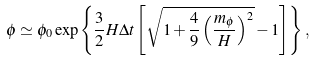Convert formula to latex. <formula><loc_0><loc_0><loc_500><loc_500>\phi \simeq \phi _ { 0 } \exp \left \{ \frac { 3 } { 2 } H \Delta t \left [ \sqrt { 1 + \frac { 4 } { 9 } \left ( \frac { m _ { \phi } } { H } \right ) ^ { 2 } } - 1 \right ] \right \} ,</formula> 